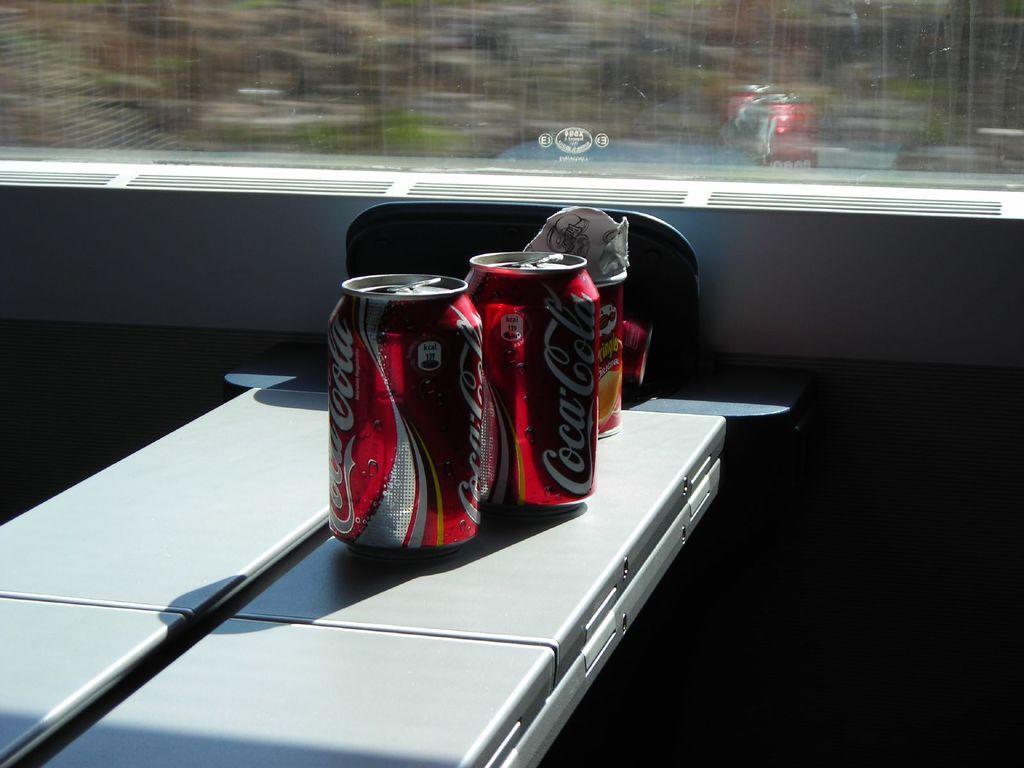How would you summarize this image in a sentence or two? There are two coca cola tins and some other objects placed on a table and there is a glass window in the background. 